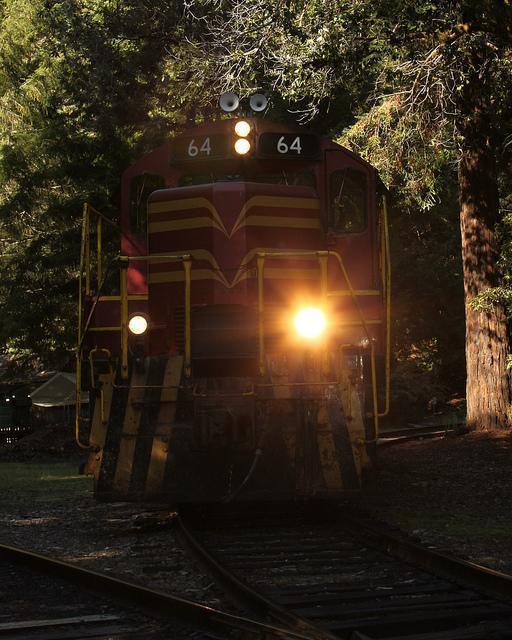How many people are in the picture?
Give a very brief answer. 0. 